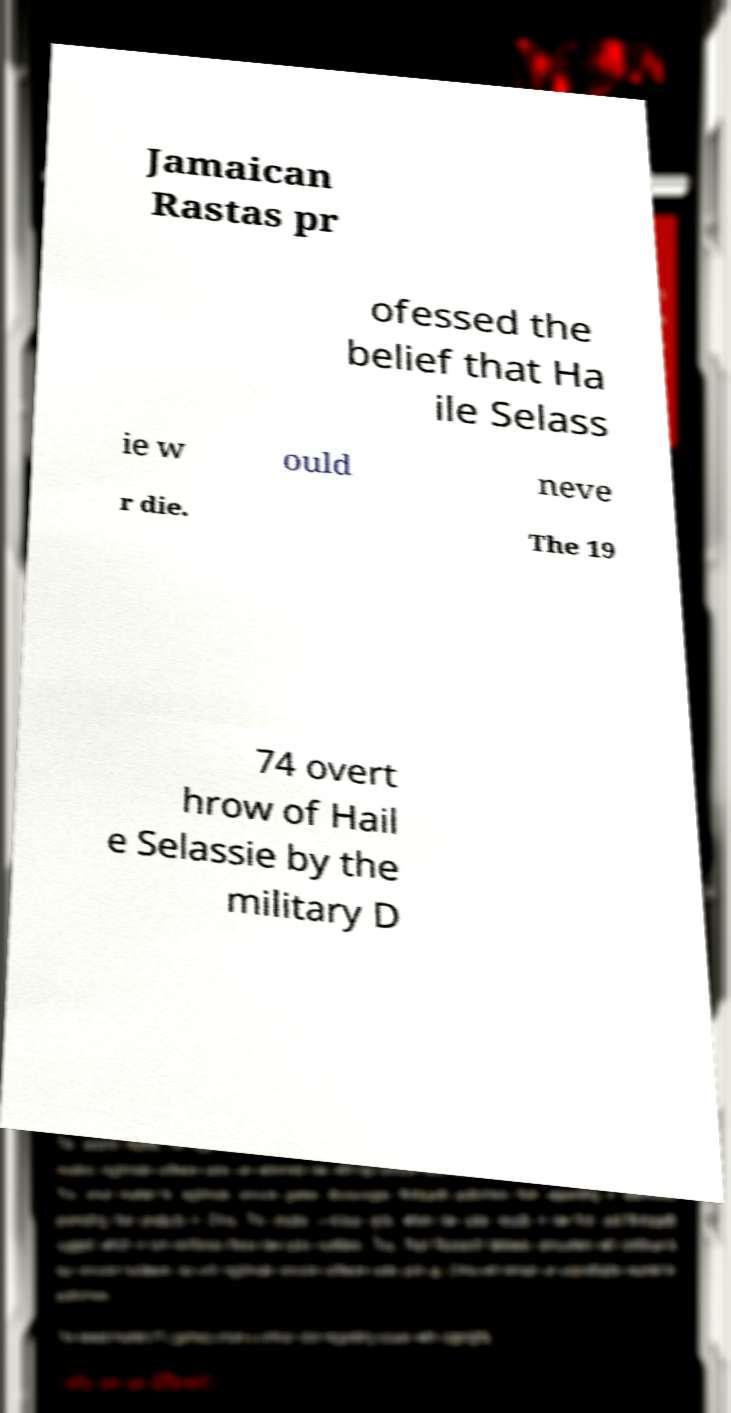Can you read and provide the text displayed in the image?This photo seems to have some interesting text. Can you extract and type it out for me? Jamaican Rastas pr ofessed the belief that Ha ile Selass ie w ould neve r die. The 19 74 overt hrow of Hail e Selassie by the military D 